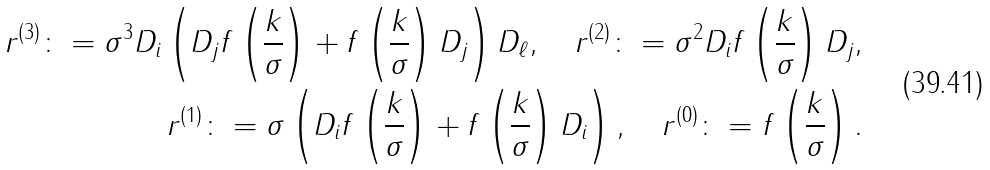<formula> <loc_0><loc_0><loc_500><loc_500>r ^ { ( 3 ) } \colon = \sigma ^ { 3 } D _ { i } \left ( D _ { j } f \left ( \frac { k } { \sigma } \right ) + f \left ( \frac { k } { \sigma } \right ) D _ { j } \right ) D _ { \ell } , \quad r ^ { ( 2 ) } \colon = \sigma ^ { 2 } D _ { i } f \left ( \frac { k } { \sigma } \right ) D _ { j } , \\ r ^ { ( 1 ) } \colon = \sigma \left ( D _ { i } f \left ( \frac { k } { \sigma } \right ) + f \left ( \frac { k } { \sigma } \right ) D _ { i } \right ) , \quad r ^ { ( 0 ) } \colon = f \left ( \frac { k } { \sigma } \right ) .</formula> 